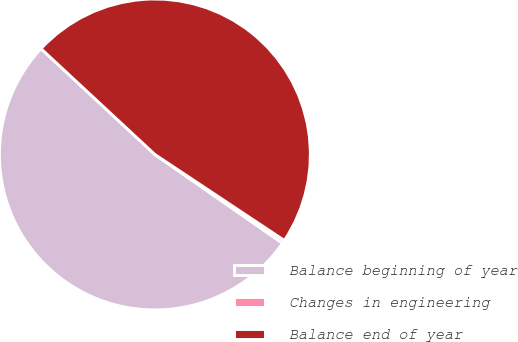Convert chart to OTSL. <chart><loc_0><loc_0><loc_500><loc_500><pie_chart><fcel>Balance beginning of year<fcel>Changes in engineering<fcel>Balance end of year<nl><fcel>52.24%<fcel>0.34%<fcel>47.41%<nl></chart> 